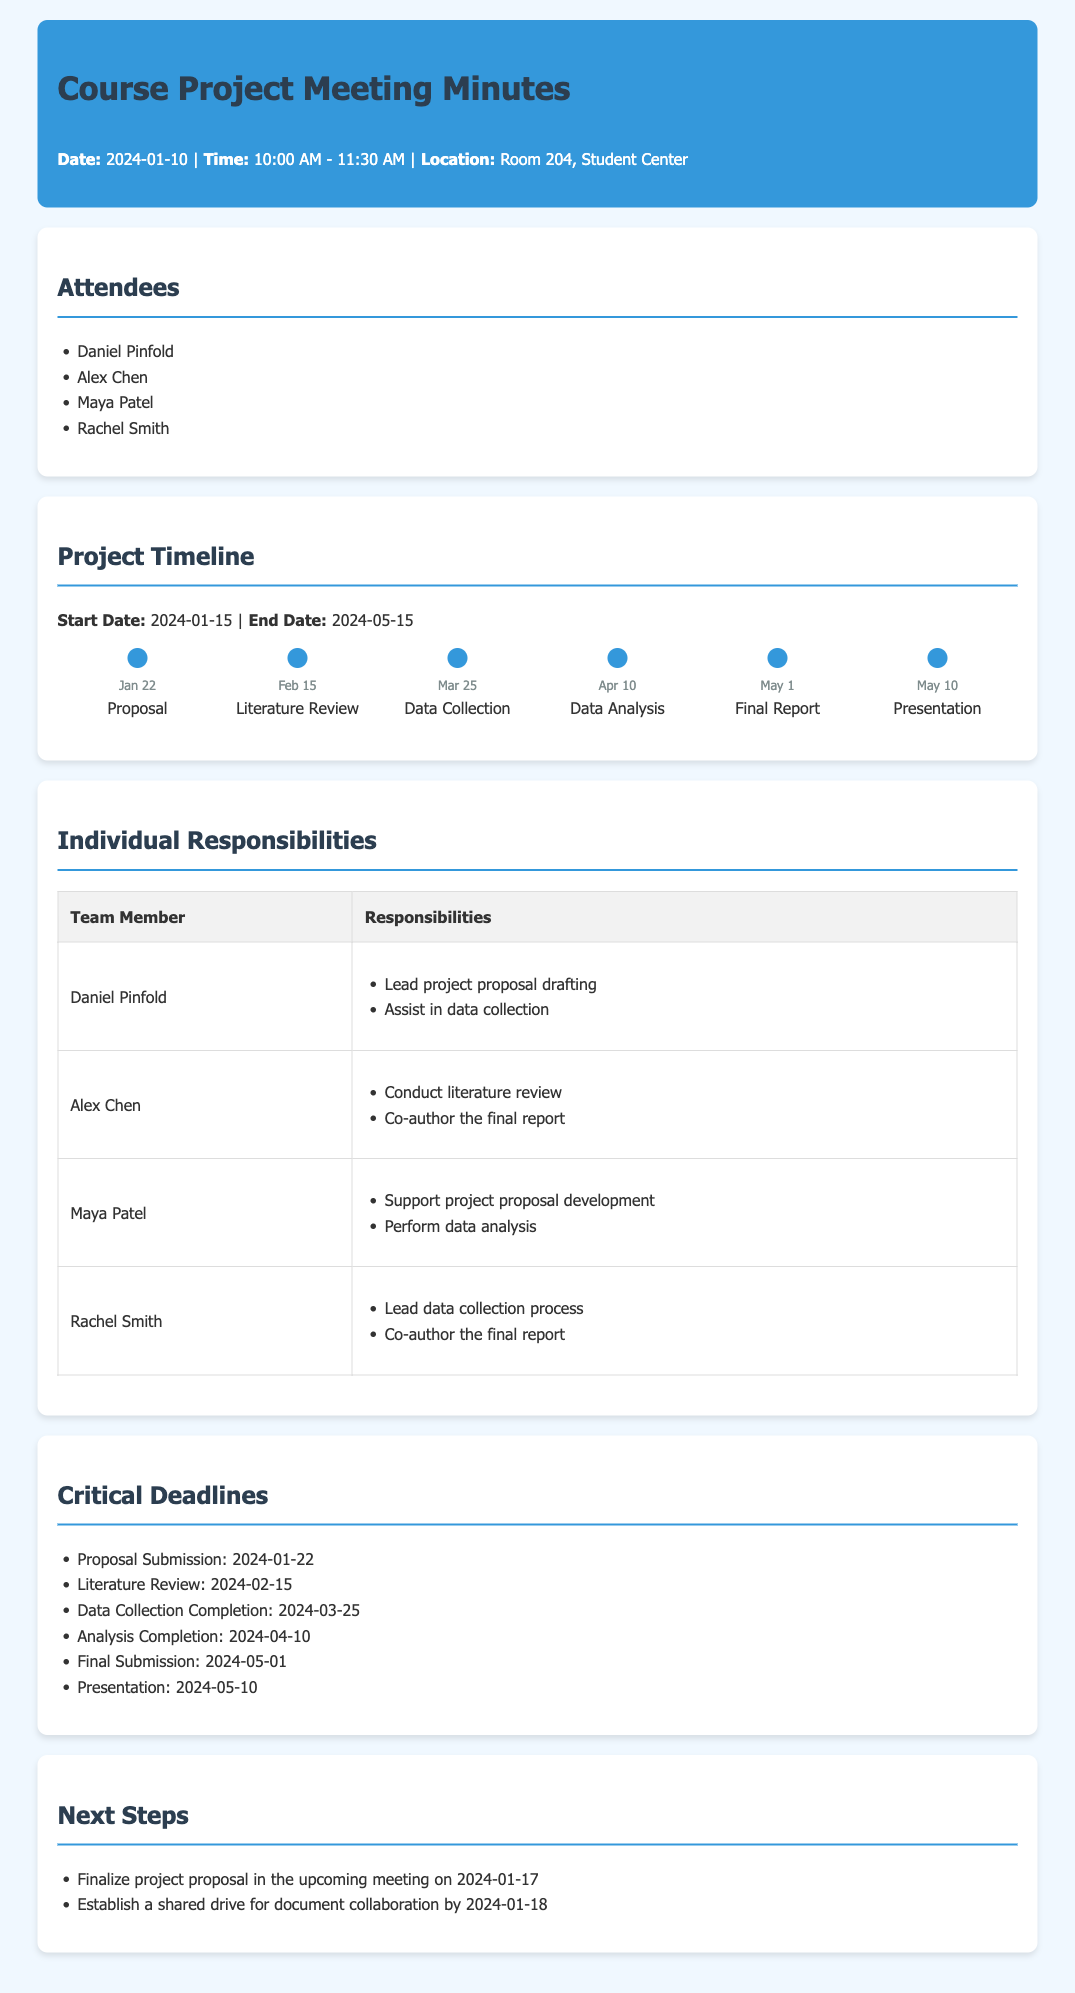What is the project start date? The project start date is mentioned under the Project Timeline section.
Answer: 2024-01-15 Who is responsible for conducting the literature review? This can be found in the Individual Responsibilities section where team members are listed with their specific tasks.
Answer: Alex Chen What is the deadline for the proposal submission? The deadline is provided in the Critical Deadlines section of the document.
Answer: 2024-01-22 How many team members are present at the meeting? The attendees are listed in the Attendees section, and we count them.
Answer: 4 What is Maya Patel's primary responsibility? This is found in the Individual Responsibilities table, detailing each member's assigned tasks.
Answer: Perform data analysis What milestone is due on March 25? The milestones are listed with their respective dates in the Project Timeline section.
Answer: Data Collection When is the next meeting to finalize the project proposal? The date is specified in the Next Steps section where upcoming plans are outlined.
Answer: 2024-01-17 Who are the co-authors of the final report? This information can be found by checking the Individual Responsibilities for those involved in reporting.
Answer: Alex Chen, Rachel Smith 